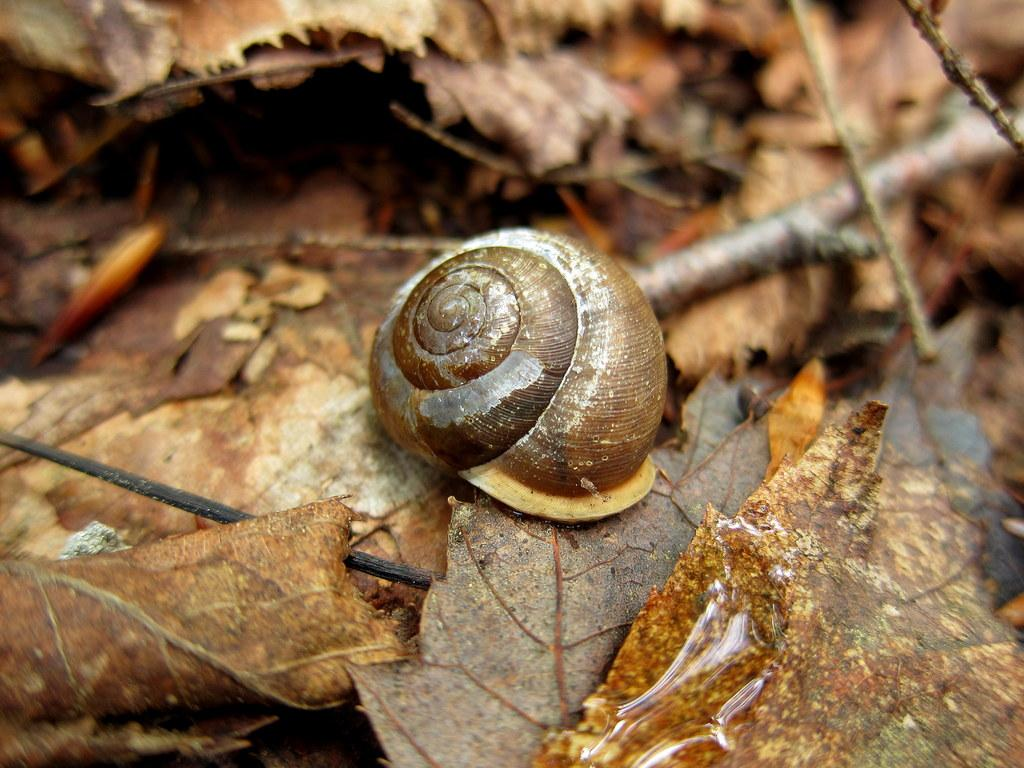What is the main subject of the image? There is a snail in the image. Where is the snail located? The snail is on the ground. What can be seen in the background of the image? The background of the image is covered with leaves and sticks. Can you tell if the image was taken during the day or night? The image was likely taken during the day. What type of credit card is the snail using to purchase items in the image? There is no credit card or purchasing activity present in the image; it features a snail on the ground with a background of leaves and sticks. 